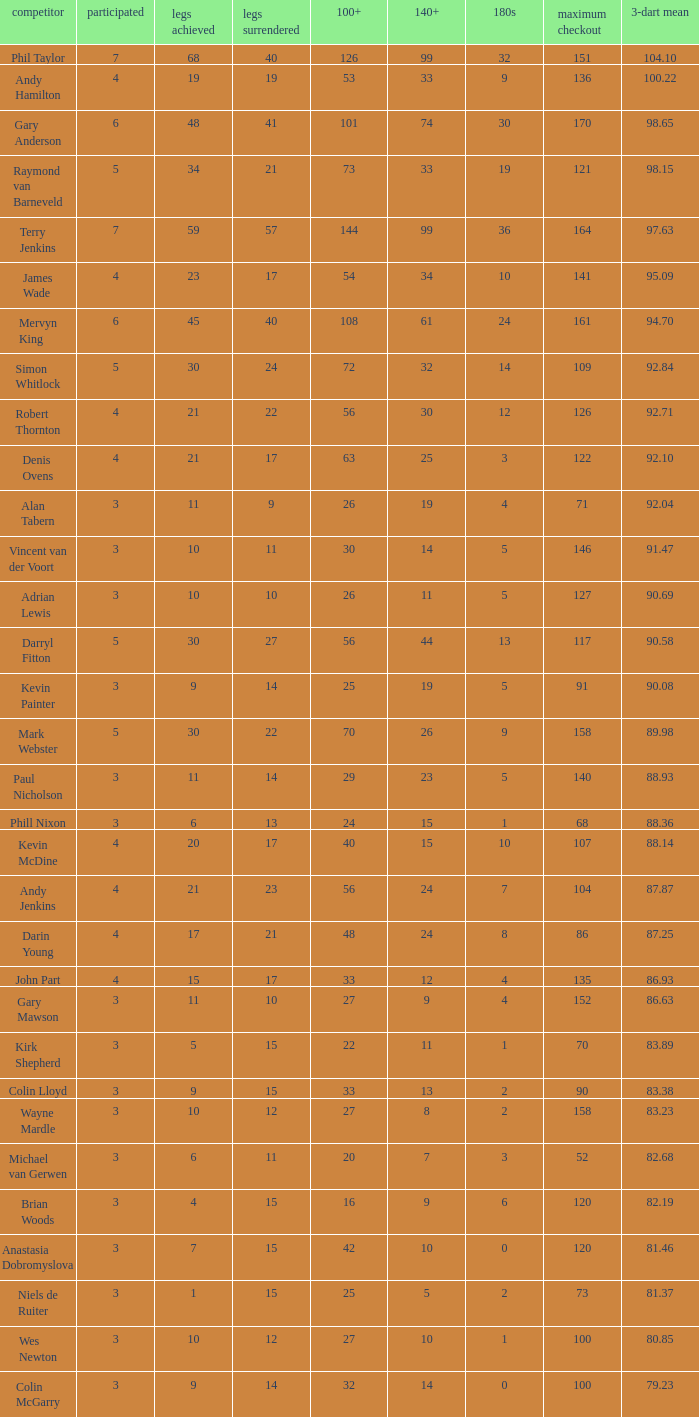What is the total number of 3-dart average when legs lost is larger than 41, and played is larger than 7? 0.0. 